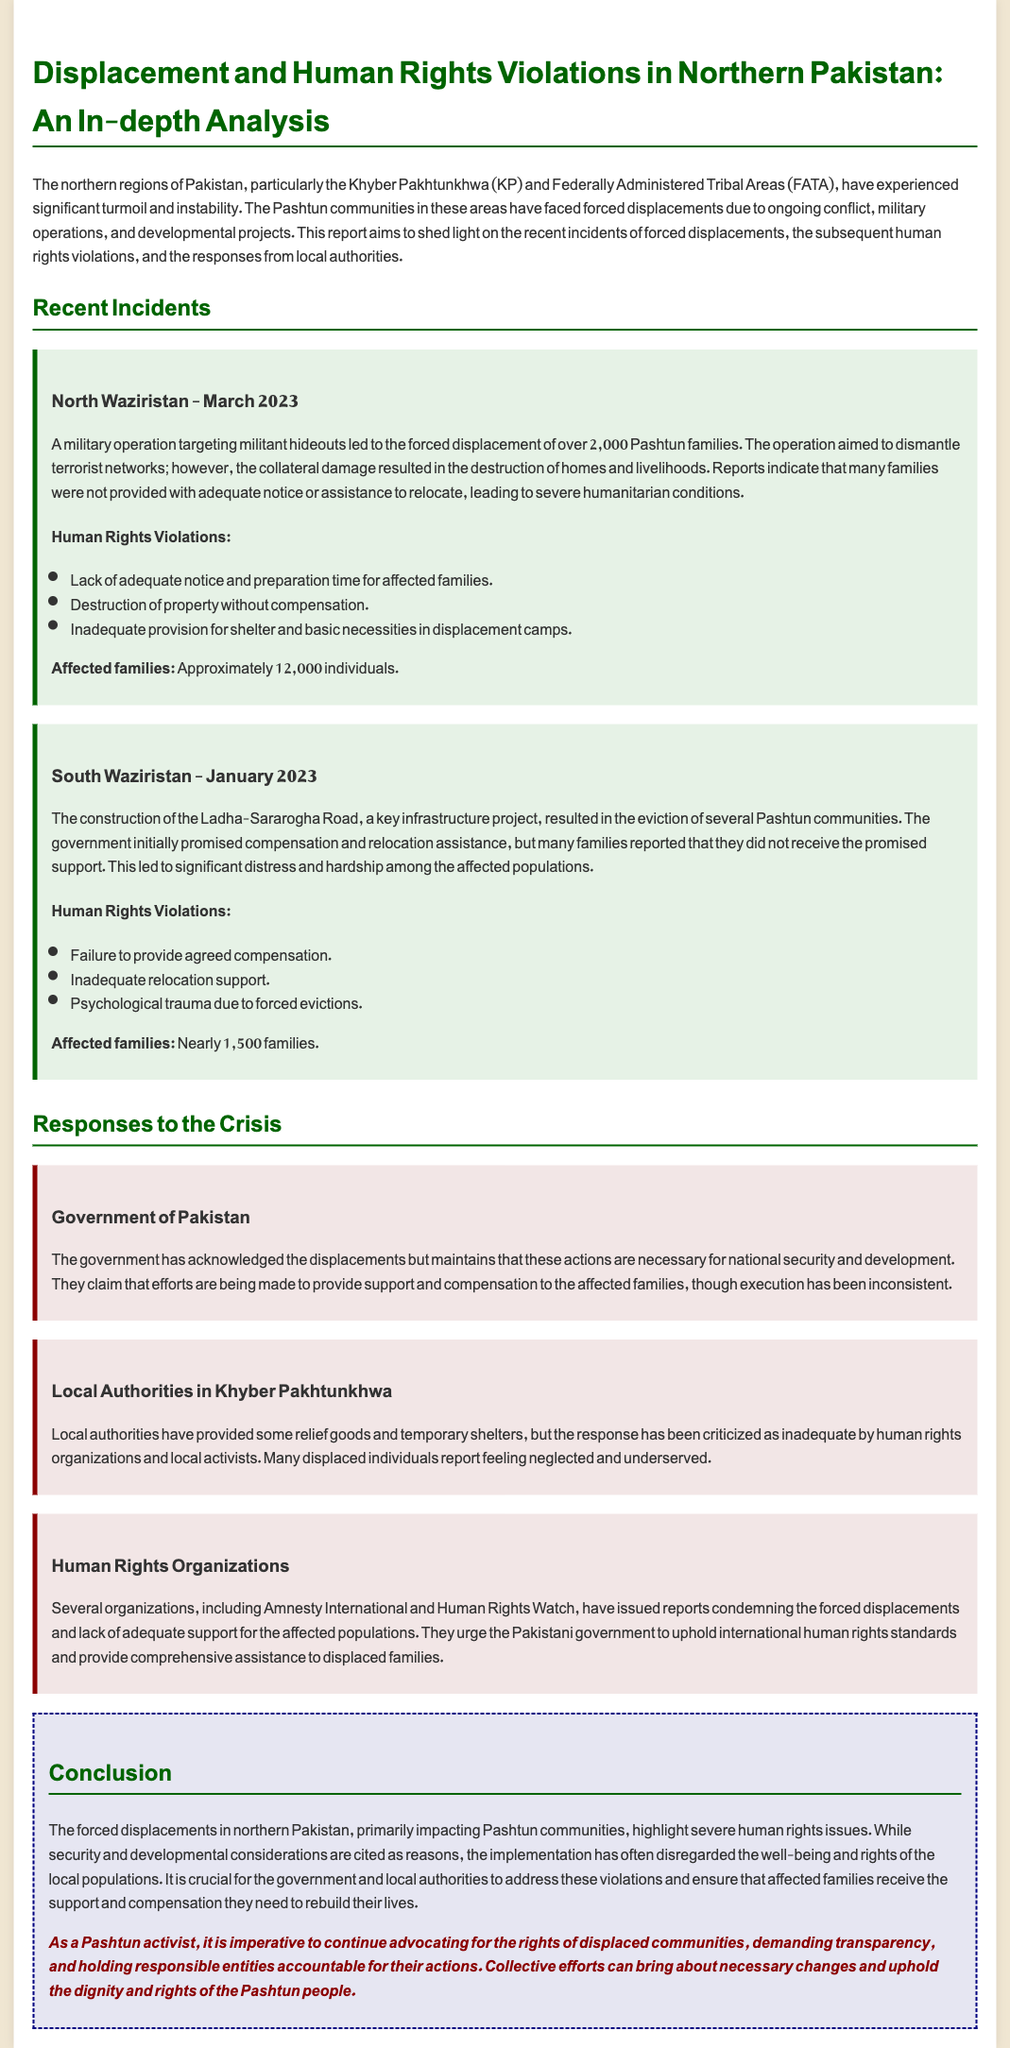What was the date of the military operation in North Waziristan? The date of the military operation targeting militant hideouts was March 2023.
Answer: March 2023 How many families were displaced in the North Waziristan incident? The report states that over 2,000 Pashtun families were displaced due to the military operation.
Answer: 2,000 families What development project caused forced evictions in South Waziristan? The construction of the Ladha-Sararogha Road resulted in the eviction of several Pashtun communities.
Answer: Ladha-Sararogha Road What was the total number of individuals affected by the North Waziristan displacements? Approximately 12,000 individuals were affected by the forced displacements in North Waziristan.
Answer: 12,000 individuals What major issue did the government of Pakistan cite as justification for displacements? The government maintains that these actions are necessary for national security and development.
Answer: National security and development Which human rights organizations have condemned the forced displacements? Amnesty International and Human Rights Watch have issued reports condemning the forced displacements.
Answer: Amnesty International and Human Rights Watch What type of assistance did local authorities provide to displaced individuals? Local authorities provided some relief goods and temporary shelters.
Answer: Relief goods and temporary shelters What psychological impact is mentioned in relation to the evictions in South Waziristan? The report highlights psychological trauma due to forced evictions among the affected families.
Answer: Psychological trauma What is the call-to-action for Pashtun activists stated in the conclusion? The call-to-action emphasizes advocating for the rights of displaced communities and demanding accountability.
Answer: Advocating for rights and demanding accountability 